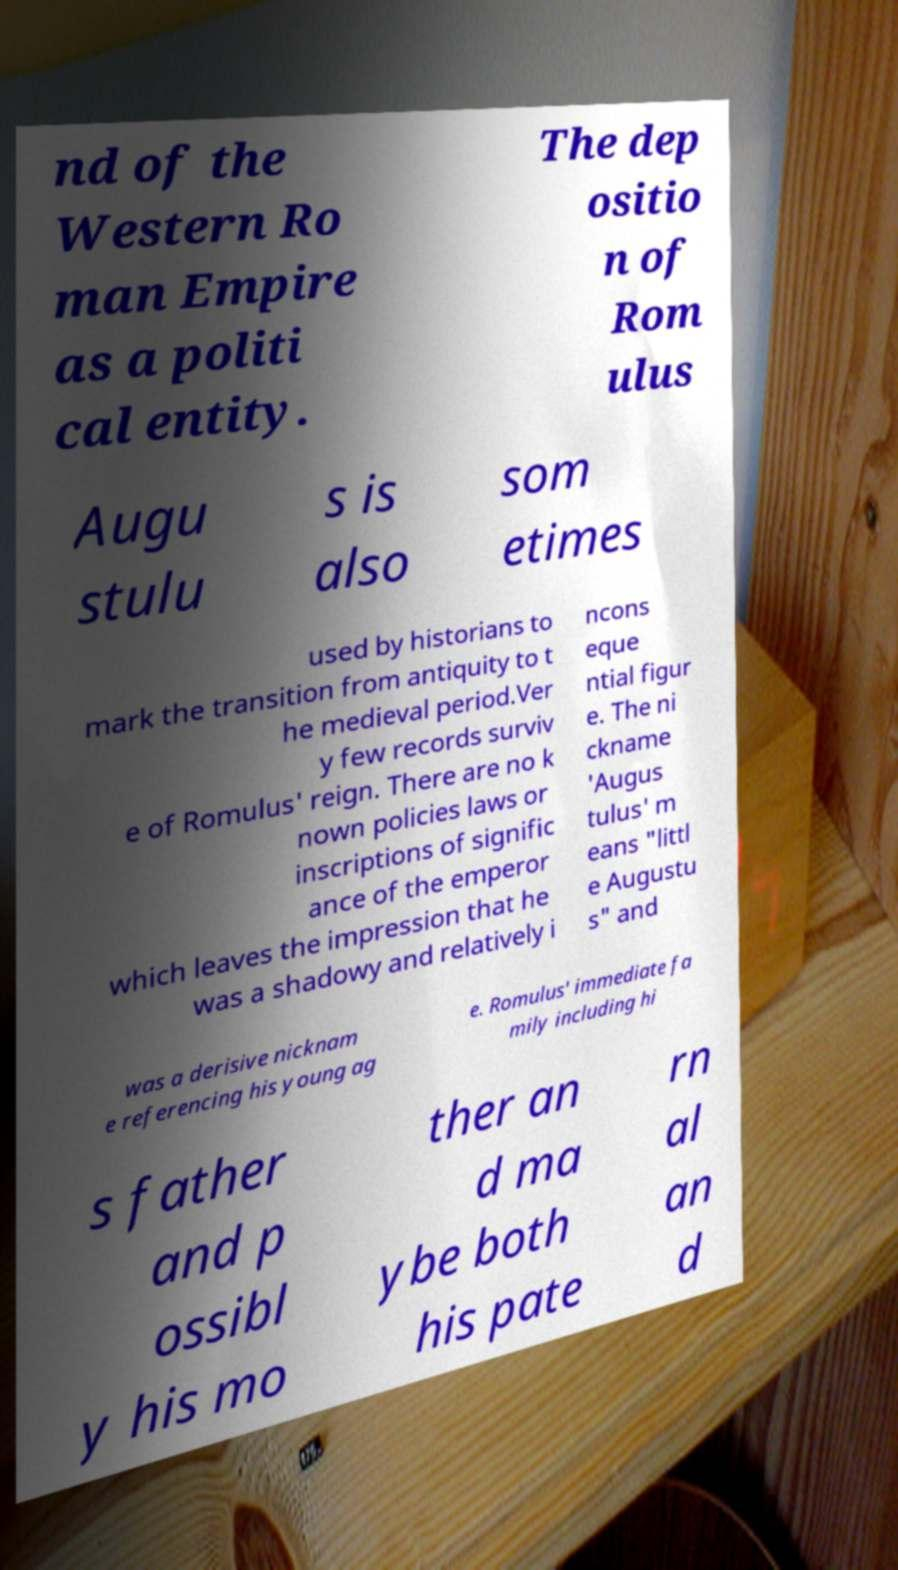Please read and relay the text visible in this image. What does it say? nd of the Western Ro man Empire as a politi cal entity. The dep ositio n of Rom ulus Augu stulu s is also som etimes used by historians to mark the transition from antiquity to t he medieval period.Ver y few records surviv e of Romulus' reign. There are no k nown policies laws or inscriptions of signific ance of the emperor which leaves the impression that he was a shadowy and relatively i ncons eque ntial figur e. The ni ckname 'Augus tulus' m eans "littl e Augustu s" and was a derisive nicknam e referencing his young ag e. Romulus' immediate fa mily including hi s father and p ossibl y his mo ther an d ma ybe both his pate rn al an d 